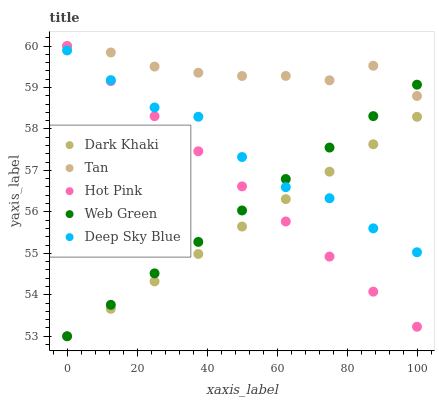Does Dark Khaki have the minimum area under the curve?
Answer yes or no. Yes. Does Tan have the maximum area under the curve?
Answer yes or no. Yes. Does Hot Pink have the minimum area under the curve?
Answer yes or no. No. Does Hot Pink have the maximum area under the curve?
Answer yes or no. No. Is Hot Pink the smoothest?
Answer yes or no. Yes. Is Deep Sky Blue the roughest?
Answer yes or no. Yes. Is Tan the smoothest?
Answer yes or no. No. Is Tan the roughest?
Answer yes or no. No. Does Dark Khaki have the lowest value?
Answer yes or no. Yes. Does Hot Pink have the lowest value?
Answer yes or no. No. Does Hot Pink have the highest value?
Answer yes or no. Yes. Does Deep Sky Blue have the highest value?
Answer yes or no. No. Is Deep Sky Blue less than Tan?
Answer yes or no. Yes. Is Tan greater than Deep Sky Blue?
Answer yes or no. Yes. Does Web Green intersect Deep Sky Blue?
Answer yes or no. Yes. Is Web Green less than Deep Sky Blue?
Answer yes or no. No. Is Web Green greater than Deep Sky Blue?
Answer yes or no. No. Does Deep Sky Blue intersect Tan?
Answer yes or no. No. 